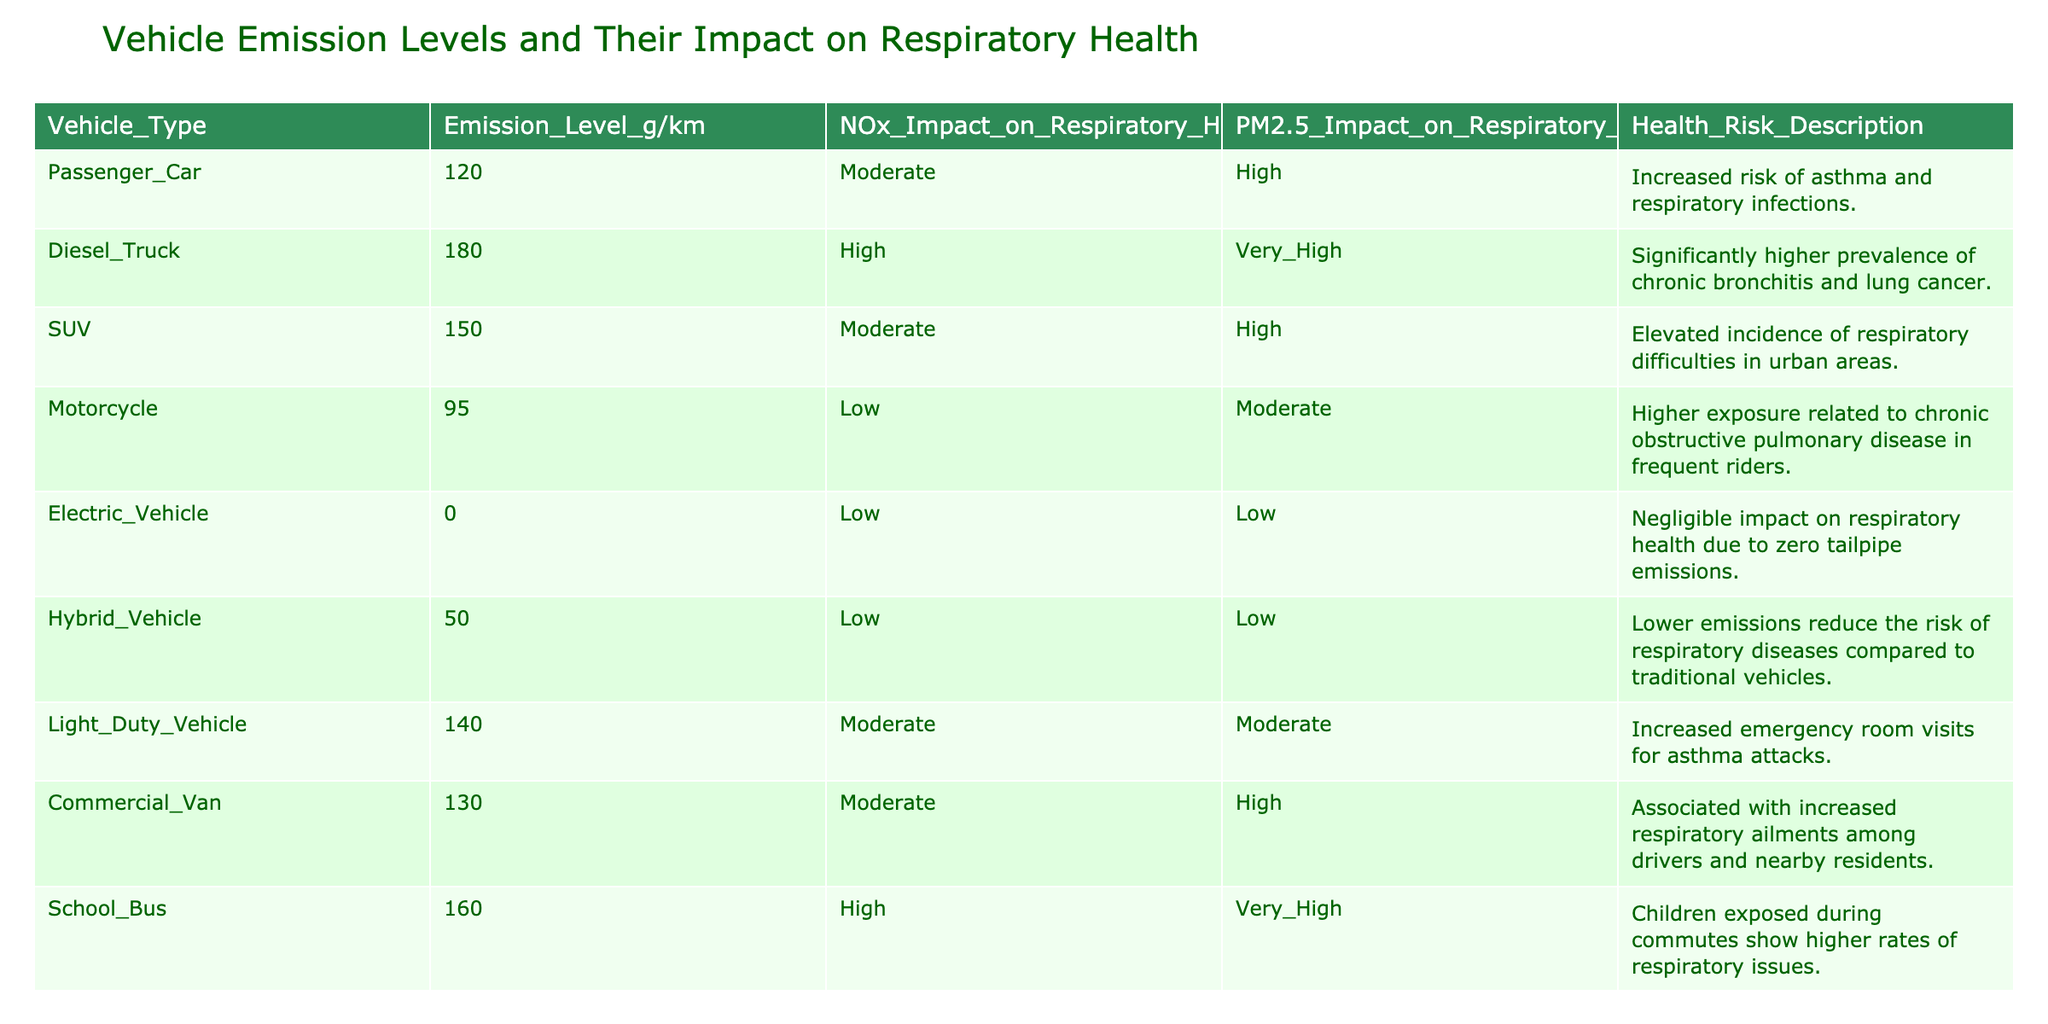What is the emission level of a Diesel Truck? According to the table, the emission level for a Diesel Truck is specified as 180 grams per kilometer.
Answer: 180 g/km Which vehicle type has the lowest PM2.5 impact on respiratory health? The table indicates that the Electric Vehicle has a PM2.5 impact categorized as "Low". No other vehicle type has a lower classification for PM2.5 impact.
Answer: Electric Vehicle What is the average emission level of all vehicle types listed in the table? To calculate the average, I first sum the emission levels: 120 + 180 + 150 + 95 + 0 + 50 + 140 + 130 + 160 = 1075. There are 9 vehicle types, so the average emission level is 1075/9 ≈ 119.44 g/km.
Answer: 119.44 g/km Is the health risk description for the SUV higher than that of the Passenger Car? The health risk description for the SUV indicates "Elevated incidence of respiratory difficulties in urban areas," while for the Passenger Car it states "Increased risk of asthma and respiratory infections." The terms used imply similar levels of health risk, but the SUV may suggest slightly higher context due to "elevated incidence." Therefore, one could interpret that the SUV has a higher health risk.
Answer: Yes What vehicle type has the highest NOx impact on respiratory health? By reviewing the NOx impact column in the table, it is evident that the Diesel Truck has a "High" rating, while the School Bus and Commercial Van also have "High" ratings, but the Diesel Truck is typically recognized as having the highest emissions; thus, it is appropriate to generalize that it has the most significant health impact.
Answer: Diesel Truck How does the emission level of a Hybrid Vehicle compare to that of a Motorcycle? The emission level for a Hybrid Vehicle is 50 g/km, whereas for a Motorcycle, it is 95 g/km. Therefore, the Hybrid Vehicle has a lower emission level than the Motorcycle by 45 g/km.
Answer: 45 g/km lower Do all vehicle types have a PM2.5 impact rating of moderate or higher? Upon checking the PM2.5 impact ratings in the table, the Electric Vehicle and Hybrid Vehicle both have "Low" ratings, which confirms that not all vehicle types meet the criteria of having moderate or higher PM2.5 impact.
Answer: No Which vehicle types are associated with very high respiratory health risks? The table shows that the Diesel Truck and School Bus are classified under "Very High" for PM2.5 impact on respiratory health, indicating they carry significant health risks related to respiratory issues.
Answer: Diesel Truck and School Bus 